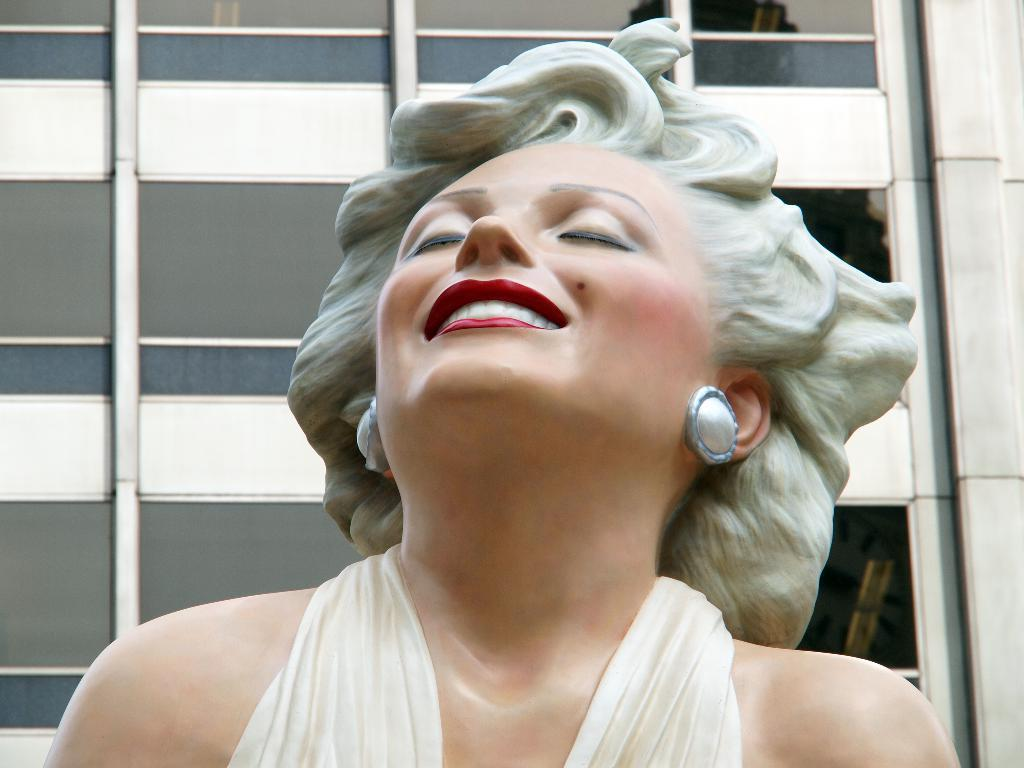What is the main subject of the image? There is a statue of a woman in the image. What can be seen behind the statue of the woman? There is a building visible behind the statue of the woman. What type of humor can be seen in the statue's expression in the image? There is no humor or expression present on the statue in the image, as it is a static object. 